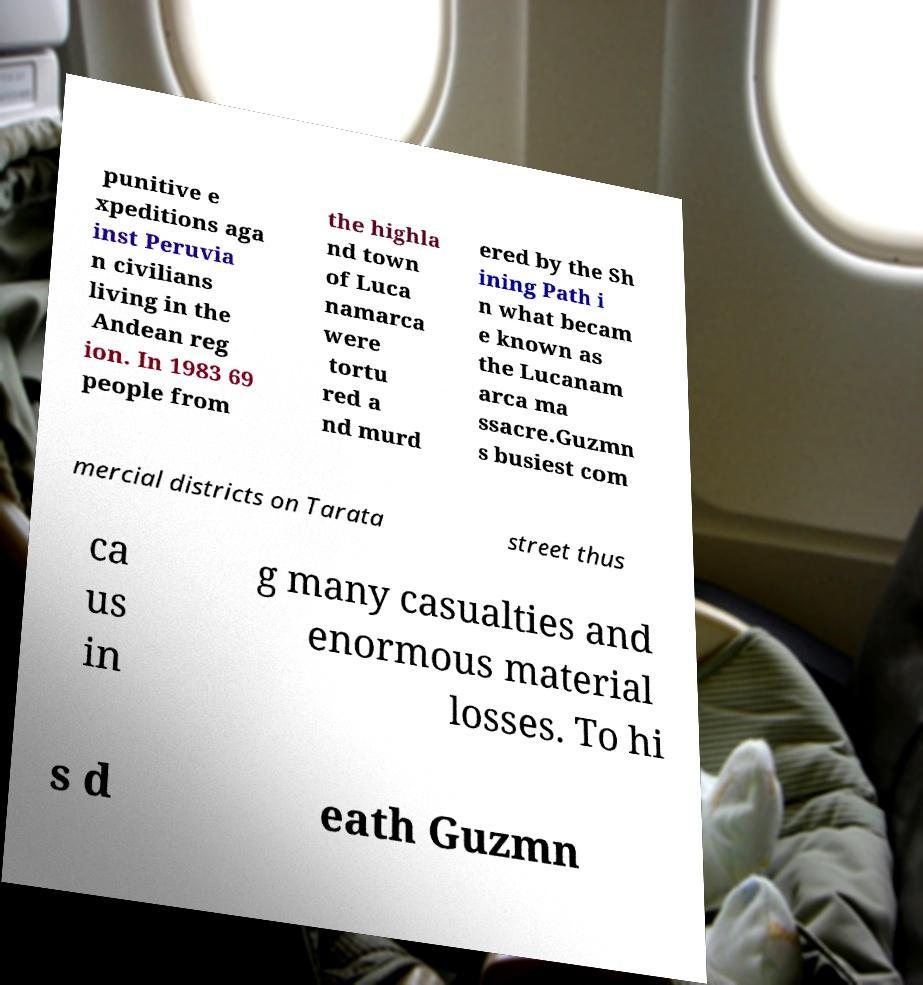Can you accurately transcribe the text from the provided image for me? punitive e xpeditions aga inst Peruvia n civilians living in the Andean reg ion. In 1983 69 people from the highla nd town of Luca namarca were tortu red a nd murd ered by the Sh ining Path i n what becam e known as the Lucanam arca ma ssacre.Guzmn s busiest com mercial districts on Tarata street thus ca us in g many casualties and enormous material losses. To hi s d eath Guzmn 